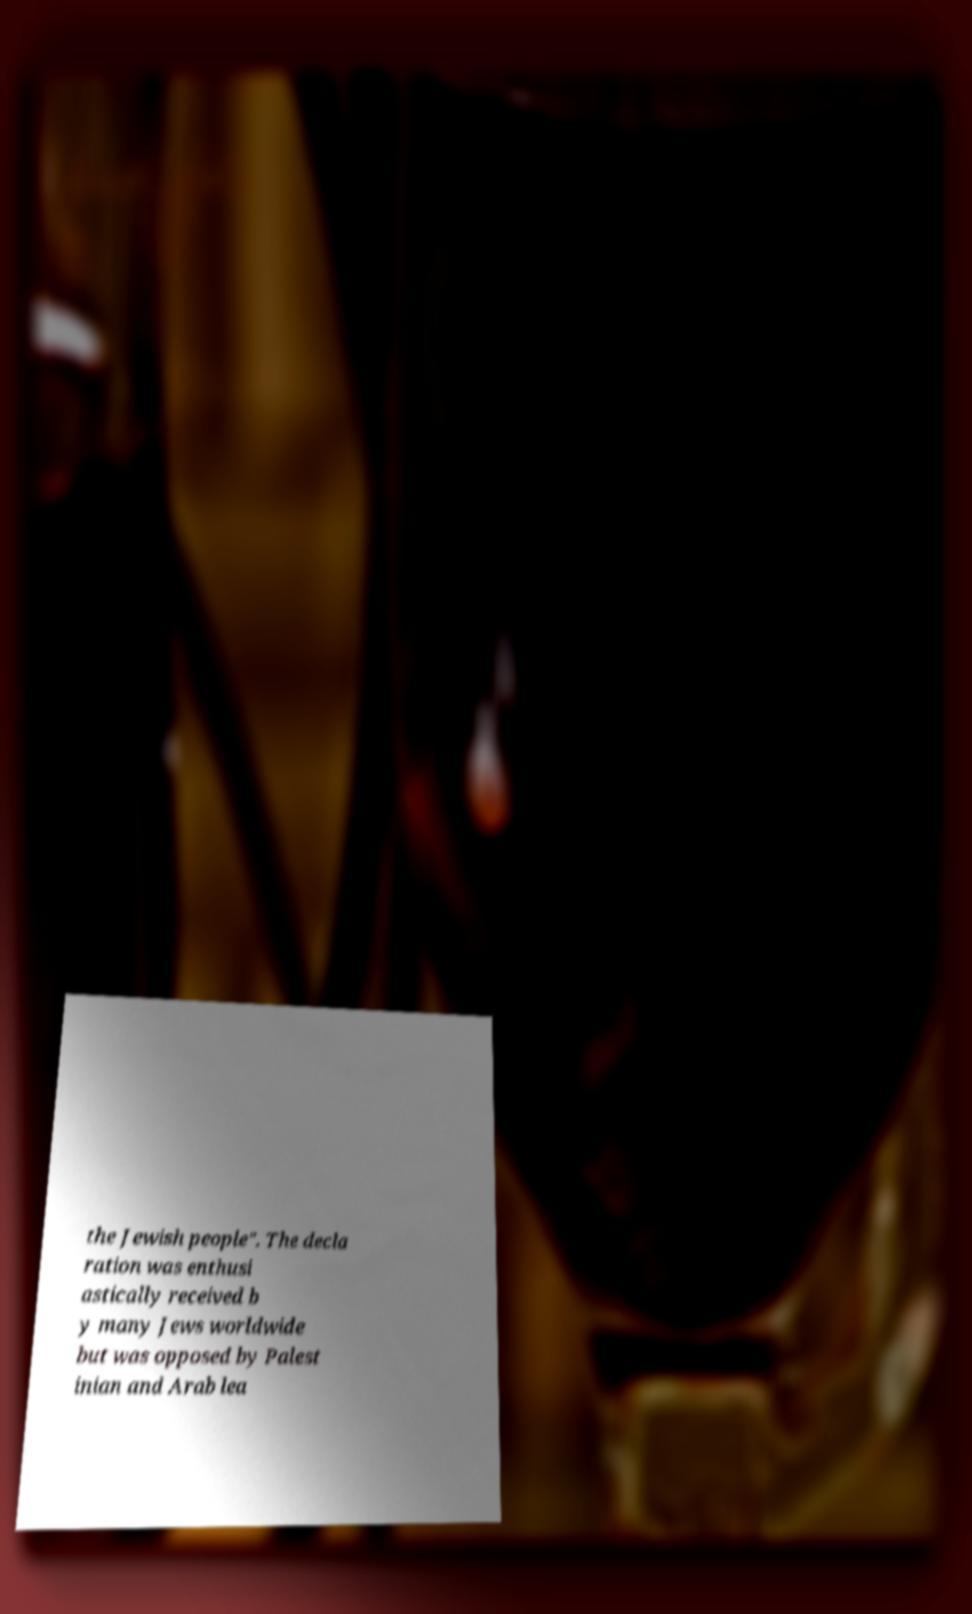Could you assist in decoding the text presented in this image and type it out clearly? the Jewish people". The decla ration was enthusi astically received b y many Jews worldwide but was opposed by Palest inian and Arab lea 